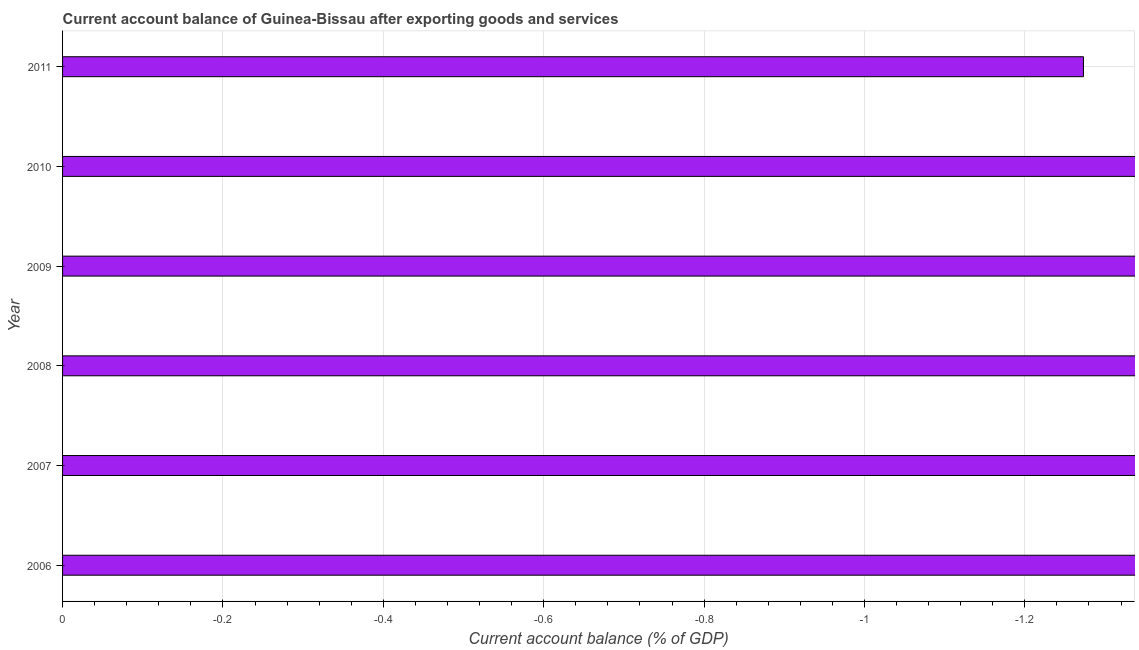What is the title of the graph?
Offer a very short reply. Current account balance of Guinea-Bissau after exporting goods and services. What is the label or title of the X-axis?
Make the answer very short. Current account balance (% of GDP). What is the label or title of the Y-axis?
Your answer should be very brief. Year. What is the current account balance in 2007?
Give a very brief answer. 0. What is the average current account balance per year?
Keep it short and to the point. 0. What is the median current account balance?
Make the answer very short. 0. In how many years, is the current account balance greater than the average current account balance taken over all years?
Your answer should be very brief. 0. Are all the bars in the graph horizontal?
Offer a terse response. Yes. What is the difference between two consecutive major ticks on the X-axis?
Offer a very short reply. 0.2. What is the Current account balance (% of GDP) in 2006?
Provide a short and direct response. 0. What is the Current account balance (% of GDP) in 2010?
Make the answer very short. 0. What is the Current account balance (% of GDP) of 2011?
Ensure brevity in your answer.  0. 